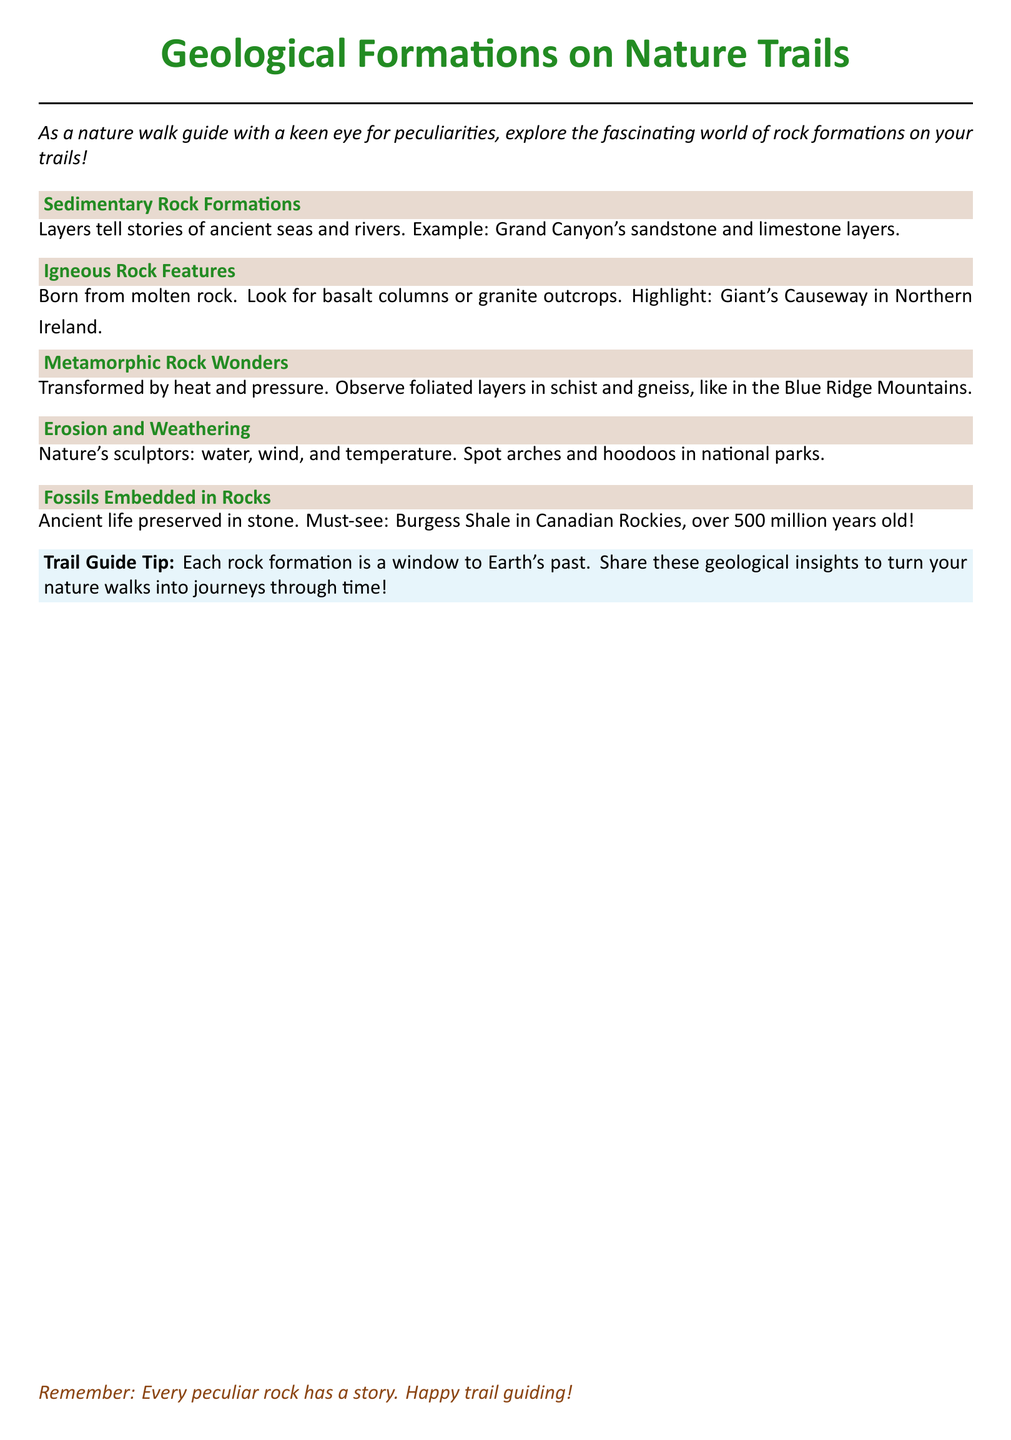What is the title of the document? The title of the document is prominently displayed at the top as the main heading.
Answer: Geological Formations on Nature Trails What type of rock is highlighted as being formed from molten rock? The document mentions a specific type of rock formed from magma that is part of one of the sections.
Answer: Igneous What is an example of a sedimentary rock formation mentioned in the document? The document provides an example of a prominent location with sedimentary rock layers.
Answer: Grand Canyon's sandstone and limestone layers Where can you find the Giant's Causeway? The document specifies the geographical location related to this remarkable rock feature.
Answer: Northern Ireland What geological feature is associated with erosion and weathering in the document? The document discusses specific features trending in nature due to natural forces acting on rocks.
Answer: Arches and hoodoos How old are the fossils in the Burgess Shale? The document gives a specific age related to ancient life preserved in a significant geological site.
Answer: Over 500 million years old What type of guide tip does the document provide? The document offers advice to enhance the experience of noting geological formations on nature walks.
Answer: Trail Guide Tip What formations can you observe in the Blue Ridge Mountains? The document identifies a specific type of metamorphic rock that can be seen in this geographical area.
Answer: Foliated layers in schist and gneiss 